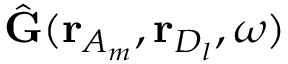Convert formula to latex. <formula><loc_0><loc_0><loc_500><loc_500>\hat { G } ( r _ { A _ { m } } , r _ { D _ { l } } , \omega )</formula> 